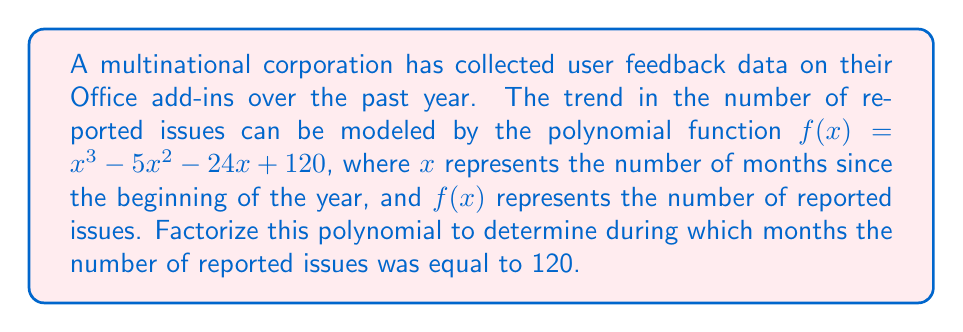Show me your answer to this math problem. To solve this problem, we need to factorize the polynomial $f(x) = x^3 - 5x^2 - 24x + 120$ and find the roots of the equation $f(x) = 120$.

Step 1: Set up the equation
$$x^3 - 5x^2 - 24x + 120 = 120$$

Step 2: Simplify
$$x^3 - 5x^2 - 24x = 0$$

Step 3: Factor out the greatest common factor
$$x(x^2 - 5x - 24) = 0$$

Step 4: Use the quadratic formula or factor the quadratic term
$$(x)(x - 8)(x + 3) = 0$$

Step 5: Solve for x
The solutions are:
$$x = 0, x = 8, \text{ or } x = -3$$

Since $x$ represents the number of months, we can discard the negative solution. Therefore, the number of reported issues was equal to 120 at the beginning of the year (x = 0) and after 8 months (x = 8).
Answer: The number of reported issues was equal to 120 during the 1st month (January) and the 9th month (September) of the year. 